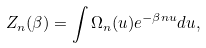<formula> <loc_0><loc_0><loc_500><loc_500>Z _ { n } ( \beta ) = \int \Omega _ { n } ( u ) e ^ { - \beta n u } d u ,</formula> 